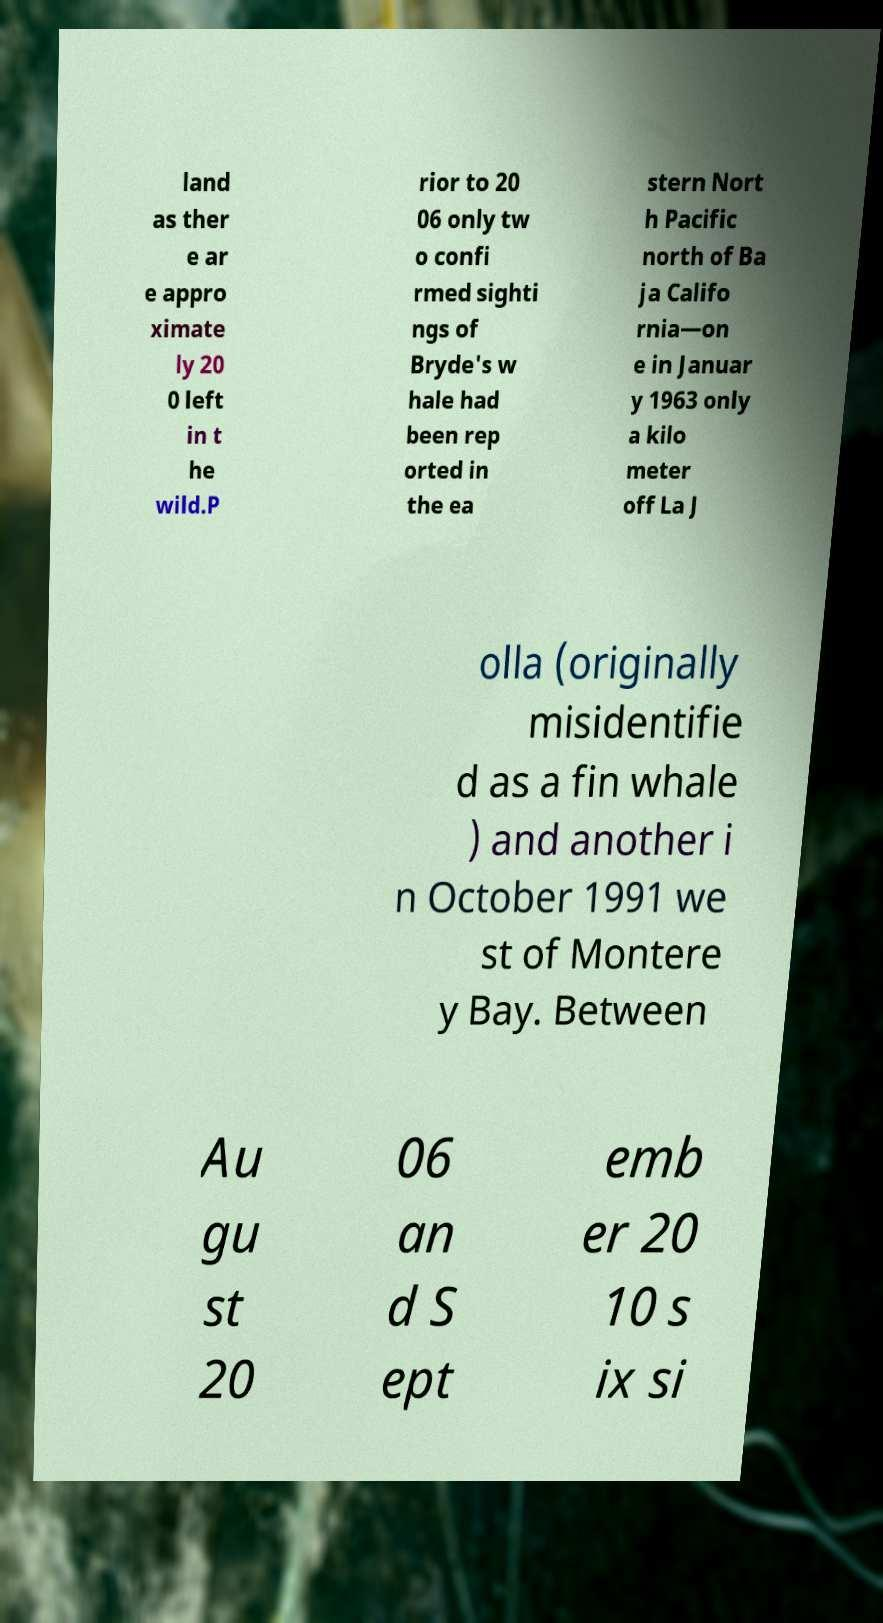Can you read and provide the text displayed in the image?This photo seems to have some interesting text. Can you extract and type it out for me? land as ther e ar e appro ximate ly 20 0 left in t he wild.P rior to 20 06 only tw o confi rmed sighti ngs of Bryde's w hale had been rep orted in the ea stern Nort h Pacific north of Ba ja Califo rnia—on e in Januar y 1963 only a kilo meter off La J olla (originally misidentifie d as a fin whale ) and another i n October 1991 we st of Montere y Bay. Between Au gu st 20 06 an d S ept emb er 20 10 s ix si 